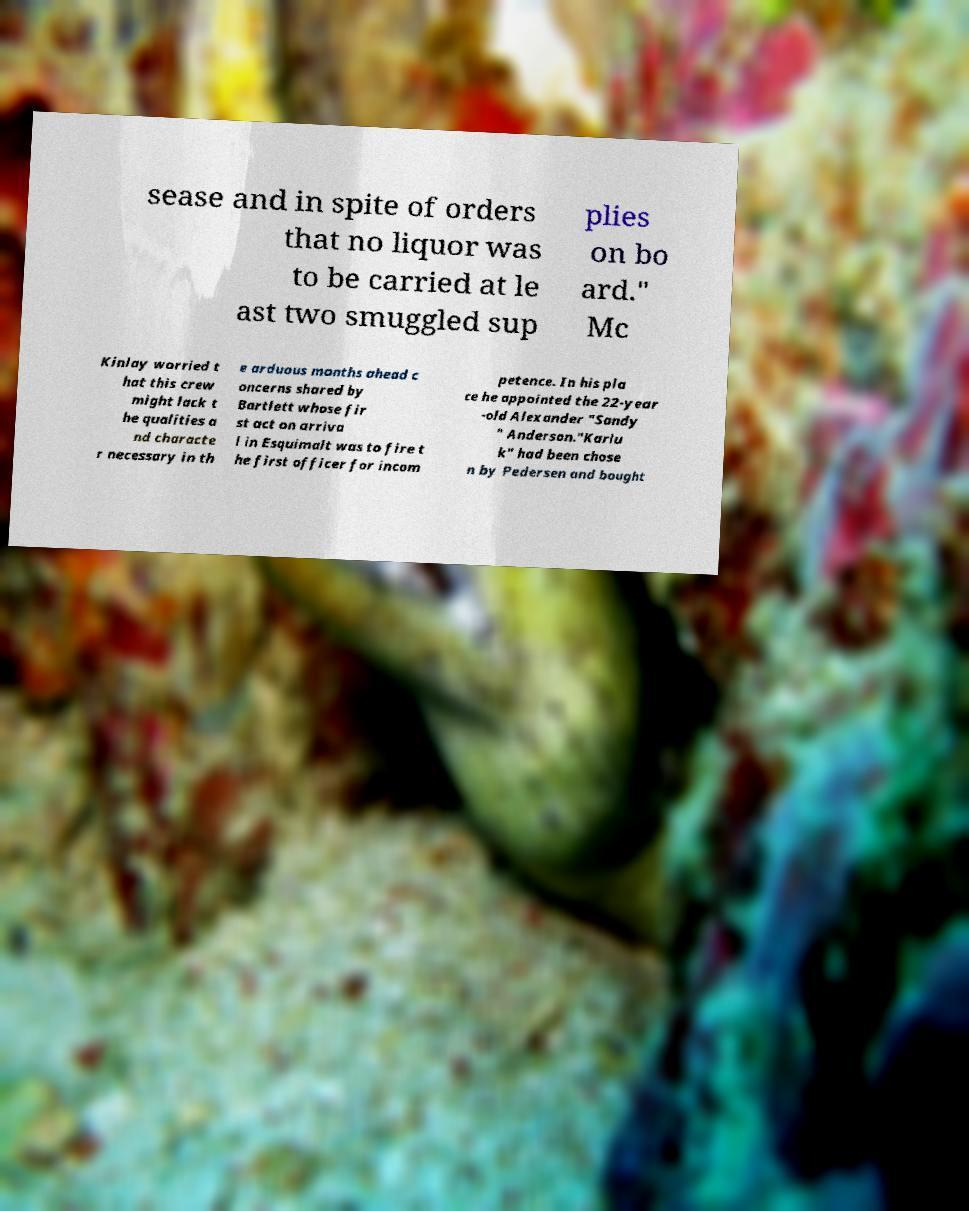Please read and relay the text visible in this image. What does it say? sease and in spite of orders that no liquor was to be carried at le ast two smuggled sup plies on bo ard." Mc Kinlay worried t hat this crew might lack t he qualities a nd characte r necessary in th e arduous months ahead c oncerns shared by Bartlett whose fir st act on arriva l in Esquimalt was to fire t he first officer for incom petence. In his pla ce he appointed the 22-year -old Alexander "Sandy " Anderson."Karlu k" had been chose n by Pedersen and bought 